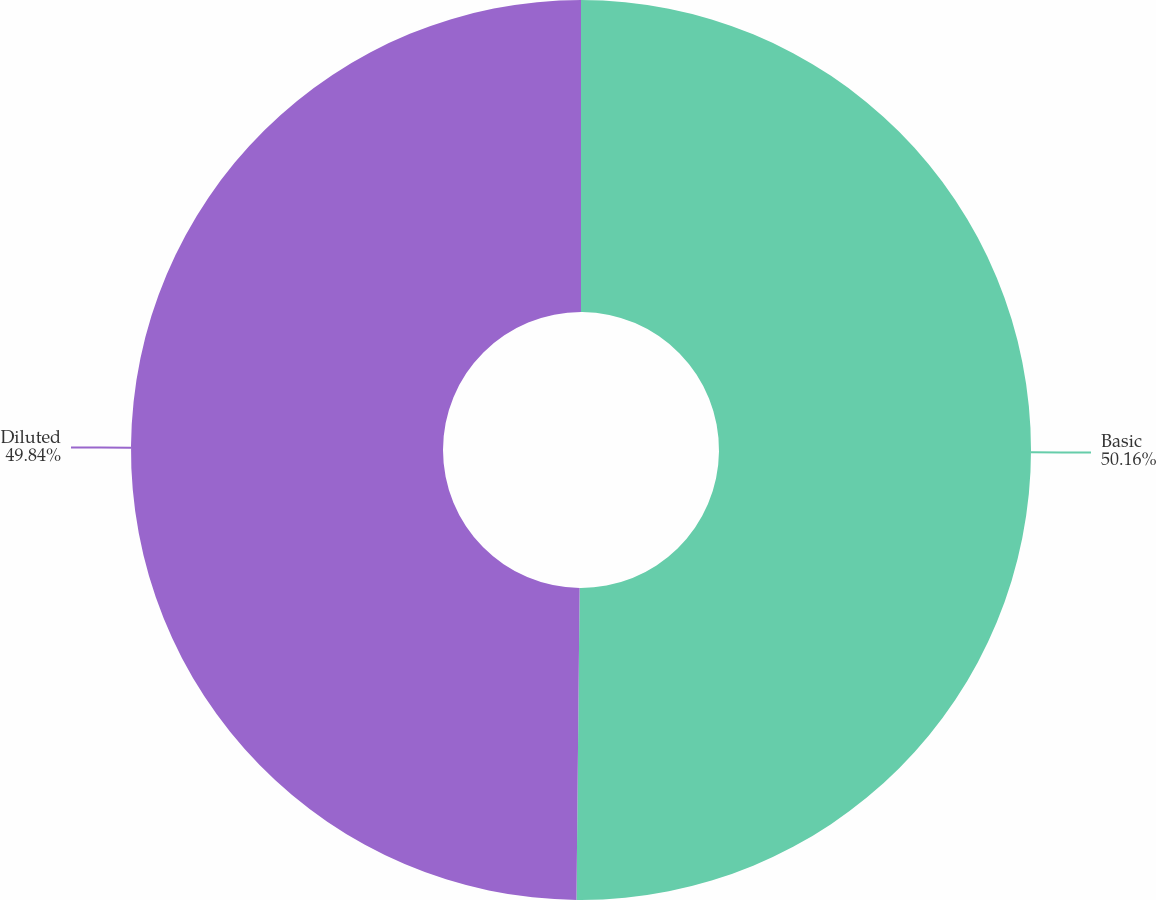Convert chart. <chart><loc_0><loc_0><loc_500><loc_500><pie_chart><fcel>Basic<fcel>Diluted<nl><fcel>50.16%<fcel>49.84%<nl></chart> 